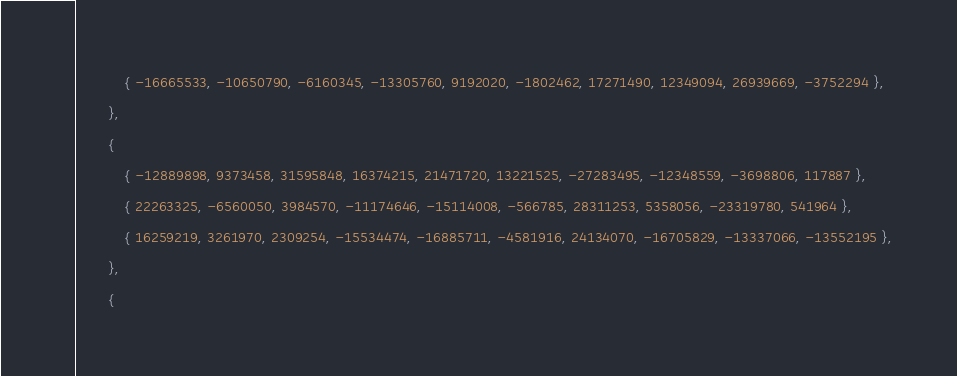<code> <loc_0><loc_0><loc_500><loc_500><_C_>            { -16665533, -10650790, -6160345, -13305760, 9192020, -1802462, 17271490, 12349094, 26939669, -3752294 },
        },
        {
            { -12889898, 9373458, 31595848, 16374215, 21471720, 13221525, -27283495, -12348559, -3698806, 117887 },
            { 22263325, -6560050, 3984570, -11174646, -15114008, -566785, 28311253, 5358056, -23319780, 541964 },
            { 16259219, 3261970, 2309254, -15534474, -16885711, -4581916, 24134070, -16705829, -13337066, -13552195 },
        },
        {</code> 